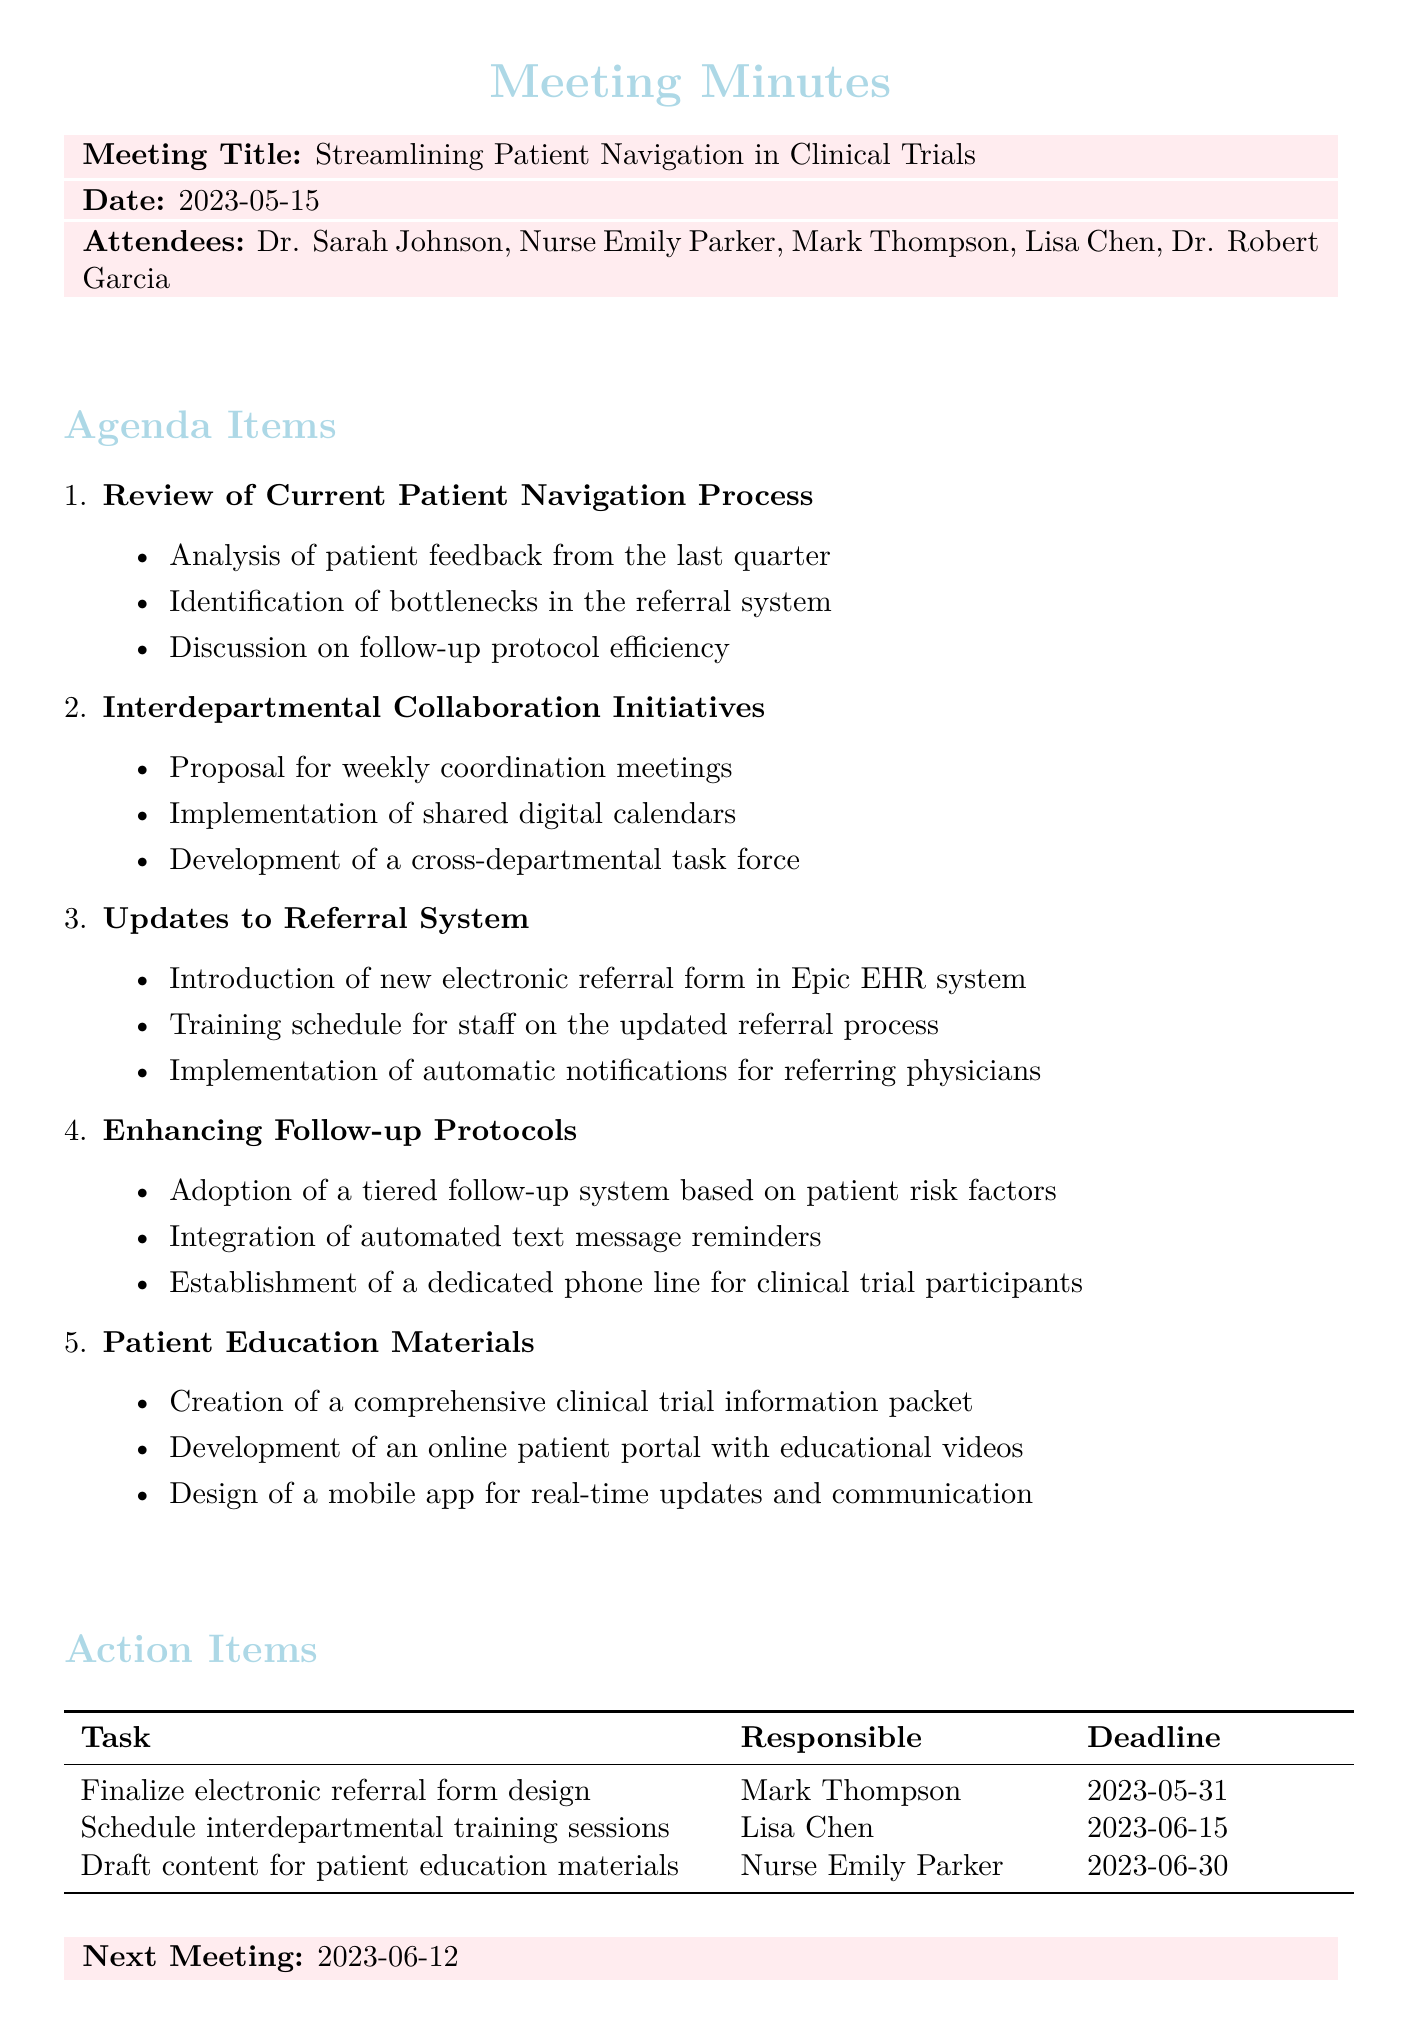What is the meeting date? The meeting date is explicitly mentioned in the document as "2023-05-15."
Answer: 2023-05-15 Who is responsible for finalizing the electronic referral form design? The document states that Mark Thompson is responsible for finalizing the electronic referral form design.
Answer: Mark Thompson What task is scheduled for completion by June 30, 2023? The document lists "Draft content for patient education materials" as the task to be completed by that date.
Answer: Draft content for patient education materials What new system will be introduced in the referral updates? The document mentions the introduction of a "new electronic referral form in Epic EHR system."
Answer: new electronic referral form in Epic EHR system How often will the interdepartmental coordination meetings take place? The document proposes "weekly coordination meetings" between the Clinical Trials and Oncology departments.
Answer: weekly What type of follow-up system will be adopted? The document states that a "tiered follow-up system based on patient risk factors" will be adopted.
Answer: tiered follow-up system based on patient risk factors What is the next meeting date? The document indicates the next meeting is scheduled for "2023-06-12."
Answer: 2023-06-12 What kind of materials will be created for patient education? The document specifies the creation of a "comprehensive clinical trial information packet."
Answer: comprehensive clinical trial information packet Who will schedule the interdepartmental training sessions? According to the document, Lisa Chen is responsible for scheduling the training sessions.
Answer: Lisa Chen 